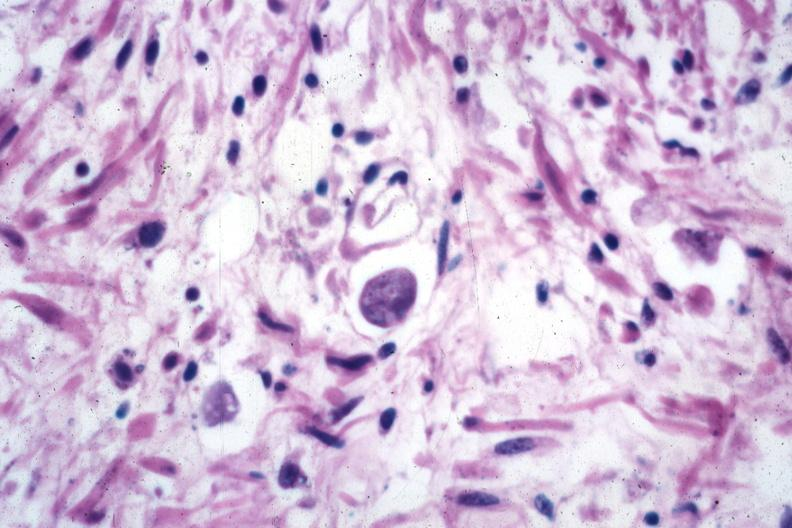what does this image show?
Answer the question using a single word or phrase. Trophozoite source 